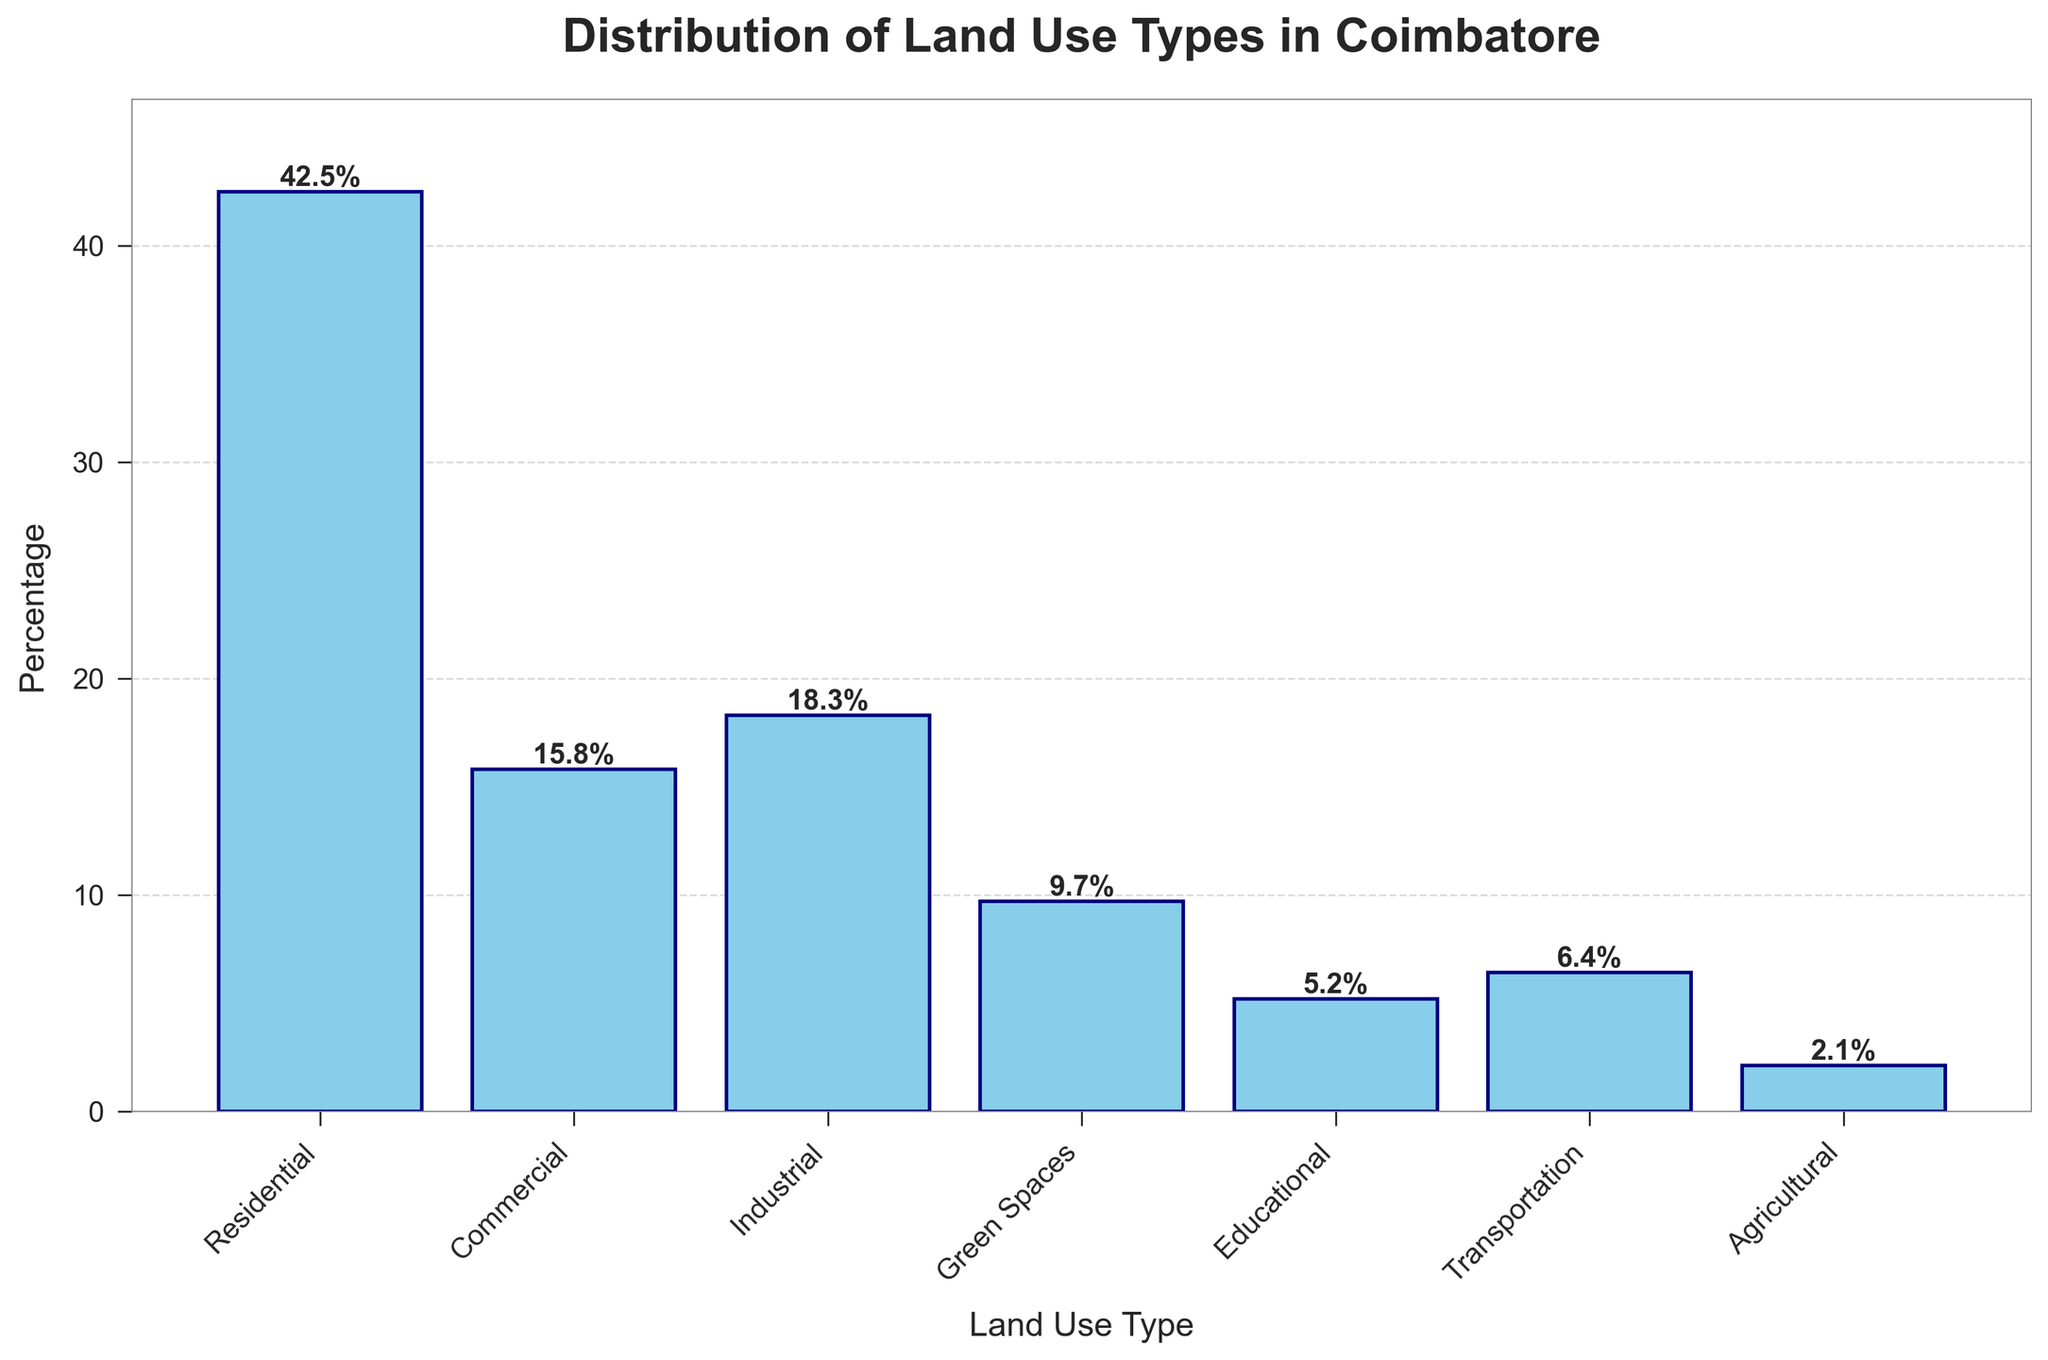What is the percentage of residential land use? The percentage corresponding to the residential bar on the plot is 42.5%.
Answer: 42.5% Which land use type has the smallest percentage? By examining the heights of the bars, Agricultural land use has the smallest percentage at 2.1%.
Answer: Agricultural How much more percentage does residential land use have compared to green spaces? Residential land use is 42.5%, and green spaces are 9.7%. The difference is 42.5% - 9.7% = 32.8%.
Answer: 32.8% If you combine the percentages of commercial and industrial land use, what is the total? Commercial is 15.8% and industrial is 18.3%. Their combined percentage is 15.8% + 18.3% = 34.1%.
Answer: 34.1% Rank the land use types from highest to lowest percentage. Based on the bar heights: Residential (42.5%), Industrial (18.3%), Commercial (15.8%), Green Spaces (9.7%), Transportation (6.4%), Educational (5.2%), Agricultural (2.1%).
Answer: Residential, Industrial, Commercial, Green Spaces, Transportation, Educational, Agricultural What is the difference between the percentage of residential and commercial land use types? Residential is 42.5% and commercial is 15.8%. The difference is 42.5% - 15.8% = 26.7%.
Answer: 26.7% What fraction of the land use is dedicated to transportation out of the total percentage shown? The total percentage summing all land use types is 100%. Transportation is 6.4%. The fraction is 6.4 / 100 = 0.064 or 6.4%.
Answer: 6.4% How does the percentage of green spaces compare to the sum of agricultural and educational land use types? Green spaces are 9.7%. Agricultural is 2.1% and educational is 5.2%. The sum of agricultural and educational is 2.1% + 5.2% = 7.3%. Green spaces (9.7%) is greater than their sum (7.3%).
Answer: Green spaces are greater Which land use type occupies more percentage, transportation or educational? From the bar heights, transportation is 6.4% and educational is 5.2%. Transportation occupies a larger percentage.
Answer: Transportation 